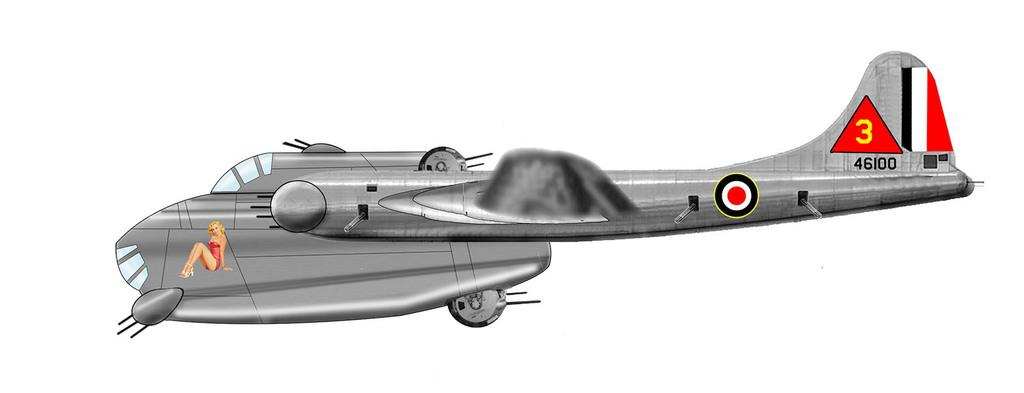<image>
Describe the image concisely. A red triangle with the number three is on the rear of a drawing of an old war plane with a girl on the front. 